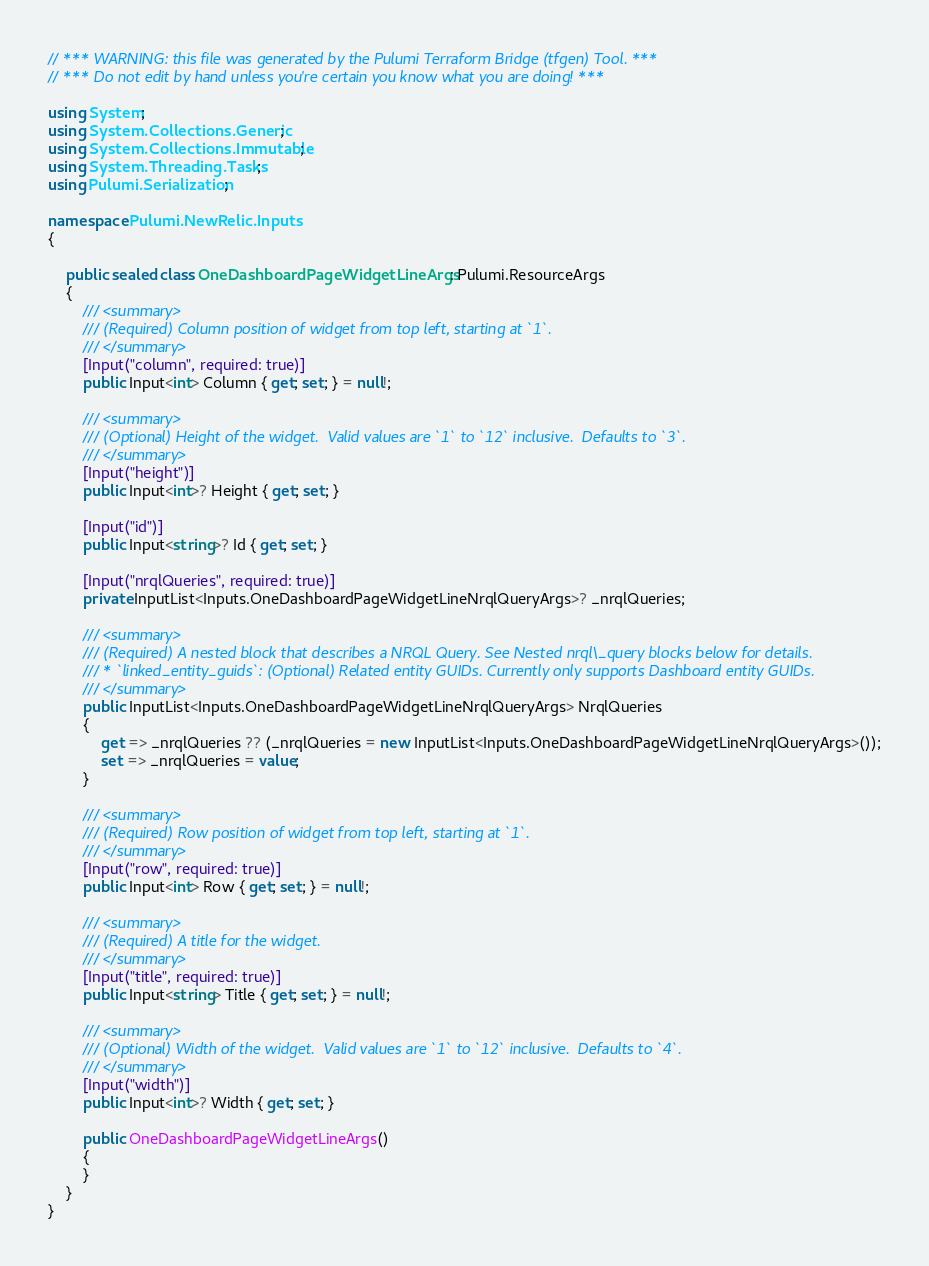Convert code to text. <code><loc_0><loc_0><loc_500><loc_500><_C#_>// *** WARNING: this file was generated by the Pulumi Terraform Bridge (tfgen) Tool. ***
// *** Do not edit by hand unless you're certain you know what you are doing! ***

using System;
using System.Collections.Generic;
using System.Collections.Immutable;
using System.Threading.Tasks;
using Pulumi.Serialization;

namespace Pulumi.NewRelic.Inputs
{

    public sealed class OneDashboardPageWidgetLineArgs : Pulumi.ResourceArgs
    {
        /// <summary>
        /// (Required) Column position of widget from top left, starting at `1`.
        /// </summary>
        [Input("column", required: true)]
        public Input<int> Column { get; set; } = null!;

        /// <summary>
        /// (Optional) Height of the widget.  Valid values are `1` to `12` inclusive.  Defaults to `3`.
        /// </summary>
        [Input("height")]
        public Input<int>? Height { get; set; }

        [Input("id")]
        public Input<string>? Id { get; set; }

        [Input("nrqlQueries", required: true)]
        private InputList<Inputs.OneDashboardPageWidgetLineNrqlQueryArgs>? _nrqlQueries;

        /// <summary>
        /// (Required) A nested block that describes a NRQL Query. See Nested nrql\_query blocks below for details.
        /// * `linked_entity_guids`: (Optional) Related entity GUIDs. Currently only supports Dashboard entity GUIDs.
        /// </summary>
        public InputList<Inputs.OneDashboardPageWidgetLineNrqlQueryArgs> NrqlQueries
        {
            get => _nrqlQueries ?? (_nrqlQueries = new InputList<Inputs.OneDashboardPageWidgetLineNrqlQueryArgs>());
            set => _nrqlQueries = value;
        }

        /// <summary>
        /// (Required) Row position of widget from top left, starting at `1`.
        /// </summary>
        [Input("row", required: true)]
        public Input<int> Row { get; set; } = null!;

        /// <summary>
        /// (Required) A title for the widget.
        /// </summary>
        [Input("title", required: true)]
        public Input<string> Title { get; set; } = null!;

        /// <summary>
        /// (Optional) Width of the widget.  Valid values are `1` to `12` inclusive.  Defaults to `4`.
        /// </summary>
        [Input("width")]
        public Input<int>? Width { get; set; }

        public OneDashboardPageWidgetLineArgs()
        {
        }
    }
}
</code> 